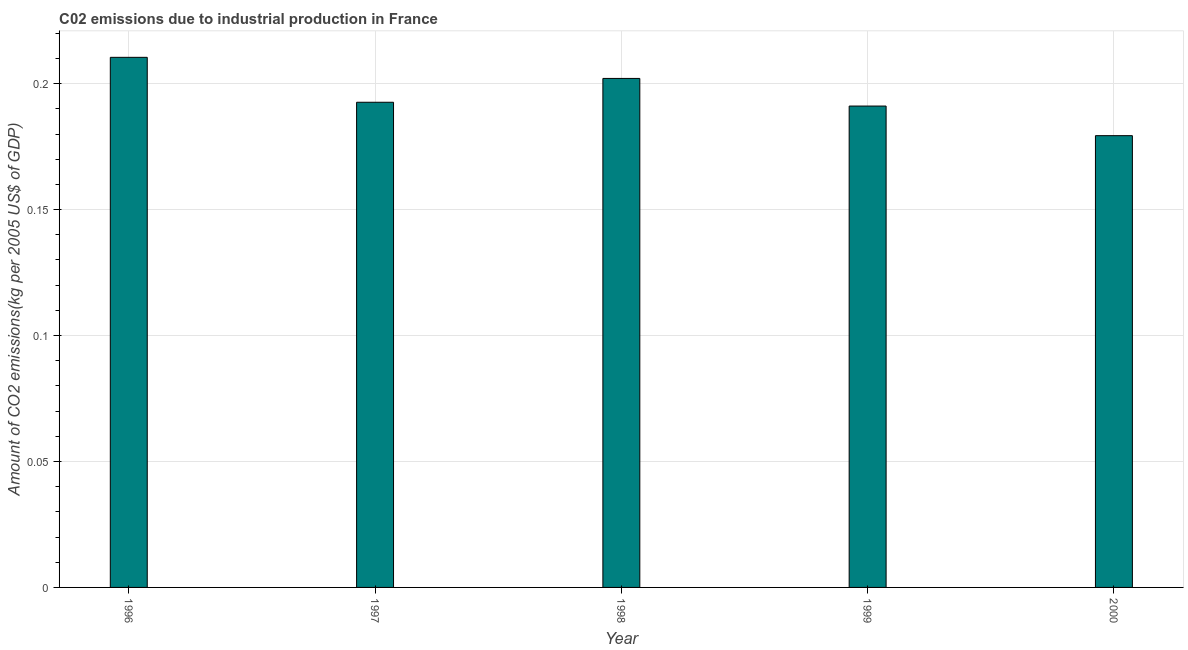Does the graph contain any zero values?
Give a very brief answer. No. Does the graph contain grids?
Ensure brevity in your answer.  Yes. What is the title of the graph?
Your answer should be very brief. C02 emissions due to industrial production in France. What is the label or title of the Y-axis?
Offer a very short reply. Amount of CO2 emissions(kg per 2005 US$ of GDP). What is the amount of co2 emissions in 2000?
Provide a short and direct response. 0.18. Across all years, what is the maximum amount of co2 emissions?
Make the answer very short. 0.21. Across all years, what is the minimum amount of co2 emissions?
Offer a terse response. 0.18. What is the sum of the amount of co2 emissions?
Provide a succinct answer. 0.98. What is the difference between the amount of co2 emissions in 1999 and 2000?
Provide a succinct answer. 0.01. What is the average amount of co2 emissions per year?
Keep it short and to the point. 0.2. What is the median amount of co2 emissions?
Your answer should be compact. 0.19. Do a majority of the years between 1999 and 1997 (inclusive) have amount of co2 emissions greater than 0.19 kg per 2005 US$ of GDP?
Ensure brevity in your answer.  Yes. What is the ratio of the amount of co2 emissions in 1999 to that in 2000?
Keep it short and to the point. 1.07. Is the difference between the amount of co2 emissions in 1997 and 2000 greater than the difference between any two years?
Give a very brief answer. No. What is the difference between the highest and the second highest amount of co2 emissions?
Offer a terse response. 0.01. In how many years, is the amount of co2 emissions greater than the average amount of co2 emissions taken over all years?
Give a very brief answer. 2. How many bars are there?
Offer a very short reply. 5. What is the Amount of CO2 emissions(kg per 2005 US$ of GDP) of 1996?
Your answer should be compact. 0.21. What is the Amount of CO2 emissions(kg per 2005 US$ of GDP) of 1997?
Give a very brief answer. 0.19. What is the Amount of CO2 emissions(kg per 2005 US$ of GDP) in 1998?
Keep it short and to the point. 0.2. What is the Amount of CO2 emissions(kg per 2005 US$ of GDP) in 1999?
Make the answer very short. 0.19. What is the Amount of CO2 emissions(kg per 2005 US$ of GDP) of 2000?
Provide a succinct answer. 0.18. What is the difference between the Amount of CO2 emissions(kg per 2005 US$ of GDP) in 1996 and 1997?
Your answer should be compact. 0.02. What is the difference between the Amount of CO2 emissions(kg per 2005 US$ of GDP) in 1996 and 1998?
Give a very brief answer. 0.01. What is the difference between the Amount of CO2 emissions(kg per 2005 US$ of GDP) in 1996 and 1999?
Provide a short and direct response. 0.02. What is the difference between the Amount of CO2 emissions(kg per 2005 US$ of GDP) in 1996 and 2000?
Your response must be concise. 0.03. What is the difference between the Amount of CO2 emissions(kg per 2005 US$ of GDP) in 1997 and 1998?
Give a very brief answer. -0.01. What is the difference between the Amount of CO2 emissions(kg per 2005 US$ of GDP) in 1997 and 1999?
Offer a very short reply. 0. What is the difference between the Amount of CO2 emissions(kg per 2005 US$ of GDP) in 1997 and 2000?
Provide a succinct answer. 0.01. What is the difference between the Amount of CO2 emissions(kg per 2005 US$ of GDP) in 1998 and 1999?
Your response must be concise. 0.01. What is the difference between the Amount of CO2 emissions(kg per 2005 US$ of GDP) in 1998 and 2000?
Your response must be concise. 0.02. What is the difference between the Amount of CO2 emissions(kg per 2005 US$ of GDP) in 1999 and 2000?
Ensure brevity in your answer.  0.01. What is the ratio of the Amount of CO2 emissions(kg per 2005 US$ of GDP) in 1996 to that in 1997?
Your response must be concise. 1.09. What is the ratio of the Amount of CO2 emissions(kg per 2005 US$ of GDP) in 1996 to that in 1998?
Provide a short and direct response. 1.04. What is the ratio of the Amount of CO2 emissions(kg per 2005 US$ of GDP) in 1996 to that in 1999?
Your answer should be very brief. 1.1. What is the ratio of the Amount of CO2 emissions(kg per 2005 US$ of GDP) in 1996 to that in 2000?
Your response must be concise. 1.17. What is the ratio of the Amount of CO2 emissions(kg per 2005 US$ of GDP) in 1997 to that in 1998?
Make the answer very short. 0.95. What is the ratio of the Amount of CO2 emissions(kg per 2005 US$ of GDP) in 1997 to that in 1999?
Your answer should be compact. 1.01. What is the ratio of the Amount of CO2 emissions(kg per 2005 US$ of GDP) in 1997 to that in 2000?
Ensure brevity in your answer.  1.07. What is the ratio of the Amount of CO2 emissions(kg per 2005 US$ of GDP) in 1998 to that in 1999?
Your answer should be compact. 1.06. What is the ratio of the Amount of CO2 emissions(kg per 2005 US$ of GDP) in 1998 to that in 2000?
Your answer should be compact. 1.13. What is the ratio of the Amount of CO2 emissions(kg per 2005 US$ of GDP) in 1999 to that in 2000?
Your answer should be compact. 1.07. 